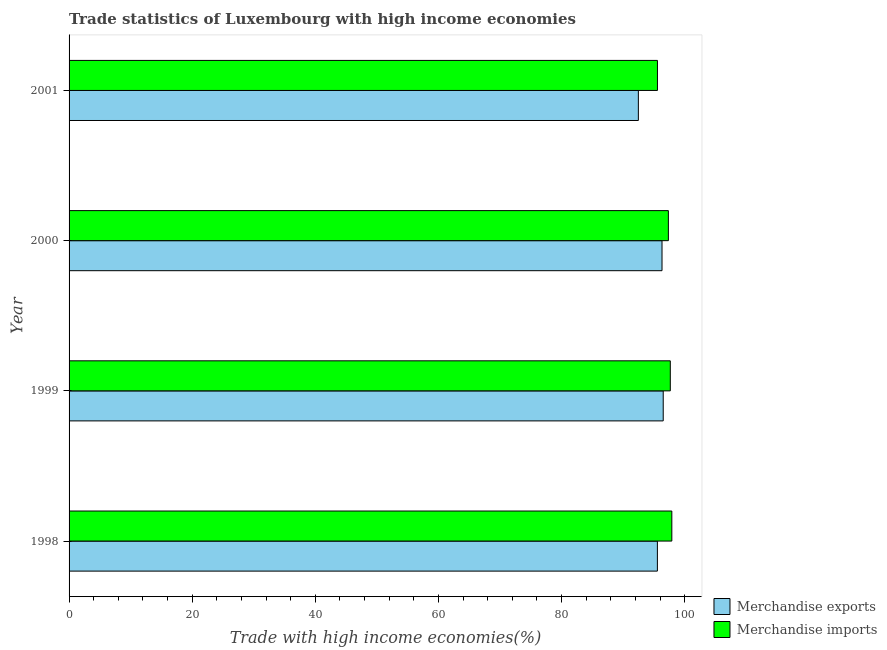How many different coloured bars are there?
Your answer should be compact. 2. Are the number of bars on each tick of the Y-axis equal?
Offer a terse response. Yes. How many bars are there on the 4th tick from the top?
Provide a short and direct response. 2. How many bars are there on the 1st tick from the bottom?
Give a very brief answer. 2. In how many cases, is the number of bars for a given year not equal to the number of legend labels?
Your answer should be compact. 0. What is the merchandise imports in 2001?
Keep it short and to the point. 95.58. Across all years, what is the maximum merchandise imports?
Provide a succinct answer. 97.91. Across all years, what is the minimum merchandise imports?
Your answer should be compact. 95.58. In which year was the merchandise imports maximum?
Offer a terse response. 1998. In which year was the merchandise imports minimum?
Make the answer very short. 2001. What is the total merchandise imports in the graph?
Your answer should be compact. 388.5. What is the difference between the merchandise exports in 1998 and that in 1999?
Your answer should be compact. -0.95. What is the difference between the merchandise exports in 1999 and the merchandise imports in 2001?
Your answer should be very brief. 0.94. What is the average merchandise imports per year?
Offer a very short reply. 97.12. In the year 1998, what is the difference between the merchandise imports and merchandise exports?
Your response must be concise. 2.34. In how many years, is the merchandise exports greater than 32 %?
Make the answer very short. 4. What is the ratio of the merchandise exports in 1999 to that in 2001?
Keep it short and to the point. 1.04. Is the difference between the merchandise imports in 2000 and 2001 greater than the difference between the merchandise exports in 2000 and 2001?
Provide a succinct answer. No. What is the difference between the highest and the second highest merchandise exports?
Ensure brevity in your answer.  0.2. What is the difference between the highest and the lowest merchandise imports?
Your answer should be compact. 2.33. In how many years, is the merchandise imports greater than the average merchandise imports taken over all years?
Provide a succinct answer. 3. Are all the bars in the graph horizontal?
Make the answer very short. Yes. How many years are there in the graph?
Offer a terse response. 4. What is the difference between two consecutive major ticks on the X-axis?
Ensure brevity in your answer.  20. Are the values on the major ticks of X-axis written in scientific E-notation?
Your answer should be compact. No. Does the graph contain any zero values?
Give a very brief answer. No. Does the graph contain grids?
Offer a terse response. No. What is the title of the graph?
Ensure brevity in your answer.  Trade statistics of Luxembourg with high income economies. Does "Pregnant women" appear as one of the legend labels in the graph?
Give a very brief answer. No. What is the label or title of the X-axis?
Your answer should be compact. Trade with high income economies(%). What is the Trade with high income economies(%) in Merchandise exports in 1998?
Give a very brief answer. 95.57. What is the Trade with high income economies(%) in Merchandise imports in 1998?
Make the answer very short. 97.91. What is the Trade with high income economies(%) of Merchandise exports in 1999?
Your answer should be very brief. 96.51. What is the Trade with high income economies(%) of Merchandise imports in 1999?
Give a very brief answer. 97.66. What is the Trade with high income economies(%) of Merchandise exports in 2000?
Make the answer very short. 96.32. What is the Trade with high income economies(%) in Merchandise imports in 2000?
Provide a short and direct response. 97.35. What is the Trade with high income economies(%) in Merchandise exports in 2001?
Your answer should be very brief. 92.48. What is the Trade with high income economies(%) in Merchandise imports in 2001?
Ensure brevity in your answer.  95.58. Across all years, what is the maximum Trade with high income economies(%) in Merchandise exports?
Offer a terse response. 96.51. Across all years, what is the maximum Trade with high income economies(%) in Merchandise imports?
Your response must be concise. 97.91. Across all years, what is the minimum Trade with high income economies(%) in Merchandise exports?
Keep it short and to the point. 92.48. Across all years, what is the minimum Trade with high income economies(%) in Merchandise imports?
Offer a very short reply. 95.58. What is the total Trade with high income economies(%) in Merchandise exports in the graph?
Offer a very short reply. 380.87. What is the total Trade with high income economies(%) of Merchandise imports in the graph?
Keep it short and to the point. 388.5. What is the difference between the Trade with high income economies(%) of Merchandise exports in 1998 and that in 1999?
Give a very brief answer. -0.95. What is the difference between the Trade with high income economies(%) in Merchandise imports in 1998 and that in 1999?
Ensure brevity in your answer.  0.25. What is the difference between the Trade with high income economies(%) of Merchandise exports in 1998 and that in 2000?
Give a very brief answer. -0.75. What is the difference between the Trade with high income economies(%) in Merchandise imports in 1998 and that in 2000?
Your answer should be very brief. 0.56. What is the difference between the Trade with high income economies(%) of Merchandise exports in 1998 and that in 2001?
Make the answer very short. 3.09. What is the difference between the Trade with high income economies(%) in Merchandise imports in 1998 and that in 2001?
Keep it short and to the point. 2.33. What is the difference between the Trade with high income economies(%) in Merchandise exports in 1999 and that in 2000?
Your answer should be very brief. 0.19. What is the difference between the Trade with high income economies(%) of Merchandise imports in 1999 and that in 2000?
Ensure brevity in your answer.  0.31. What is the difference between the Trade with high income economies(%) in Merchandise exports in 1999 and that in 2001?
Your answer should be compact. 4.04. What is the difference between the Trade with high income economies(%) of Merchandise imports in 1999 and that in 2001?
Ensure brevity in your answer.  2.09. What is the difference between the Trade with high income economies(%) in Merchandise exports in 2000 and that in 2001?
Offer a terse response. 3.84. What is the difference between the Trade with high income economies(%) in Merchandise imports in 2000 and that in 2001?
Your answer should be very brief. 1.77. What is the difference between the Trade with high income economies(%) of Merchandise exports in 1998 and the Trade with high income economies(%) of Merchandise imports in 1999?
Keep it short and to the point. -2.1. What is the difference between the Trade with high income economies(%) of Merchandise exports in 1998 and the Trade with high income economies(%) of Merchandise imports in 2000?
Your response must be concise. -1.78. What is the difference between the Trade with high income economies(%) of Merchandise exports in 1998 and the Trade with high income economies(%) of Merchandise imports in 2001?
Make the answer very short. -0.01. What is the difference between the Trade with high income economies(%) of Merchandise exports in 1999 and the Trade with high income economies(%) of Merchandise imports in 2000?
Provide a succinct answer. -0.84. What is the difference between the Trade with high income economies(%) of Merchandise exports in 1999 and the Trade with high income economies(%) of Merchandise imports in 2001?
Offer a very short reply. 0.94. What is the difference between the Trade with high income economies(%) of Merchandise exports in 2000 and the Trade with high income economies(%) of Merchandise imports in 2001?
Your answer should be very brief. 0.74. What is the average Trade with high income economies(%) in Merchandise exports per year?
Provide a short and direct response. 95.22. What is the average Trade with high income economies(%) in Merchandise imports per year?
Offer a very short reply. 97.12. In the year 1998, what is the difference between the Trade with high income economies(%) in Merchandise exports and Trade with high income economies(%) in Merchandise imports?
Keep it short and to the point. -2.34. In the year 1999, what is the difference between the Trade with high income economies(%) of Merchandise exports and Trade with high income economies(%) of Merchandise imports?
Keep it short and to the point. -1.15. In the year 2000, what is the difference between the Trade with high income economies(%) of Merchandise exports and Trade with high income economies(%) of Merchandise imports?
Offer a terse response. -1.03. In the year 2001, what is the difference between the Trade with high income economies(%) of Merchandise exports and Trade with high income economies(%) of Merchandise imports?
Ensure brevity in your answer.  -3.1. What is the ratio of the Trade with high income economies(%) of Merchandise exports in 1998 to that in 1999?
Offer a very short reply. 0.99. What is the ratio of the Trade with high income economies(%) in Merchandise imports in 1998 to that in 1999?
Give a very brief answer. 1. What is the ratio of the Trade with high income economies(%) in Merchandise exports in 1998 to that in 2001?
Keep it short and to the point. 1.03. What is the ratio of the Trade with high income economies(%) in Merchandise imports in 1998 to that in 2001?
Offer a very short reply. 1.02. What is the ratio of the Trade with high income economies(%) in Merchandise exports in 1999 to that in 2001?
Provide a succinct answer. 1.04. What is the ratio of the Trade with high income economies(%) in Merchandise imports in 1999 to that in 2001?
Give a very brief answer. 1.02. What is the ratio of the Trade with high income economies(%) in Merchandise exports in 2000 to that in 2001?
Offer a terse response. 1.04. What is the ratio of the Trade with high income economies(%) of Merchandise imports in 2000 to that in 2001?
Your response must be concise. 1.02. What is the difference between the highest and the second highest Trade with high income economies(%) in Merchandise exports?
Your response must be concise. 0.19. What is the difference between the highest and the second highest Trade with high income economies(%) of Merchandise imports?
Your answer should be compact. 0.25. What is the difference between the highest and the lowest Trade with high income economies(%) of Merchandise exports?
Provide a succinct answer. 4.04. What is the difference between the highest and the lowest Trade with high income economies(%) of Merchandise imports?
Your response must be concise. 2.33. 